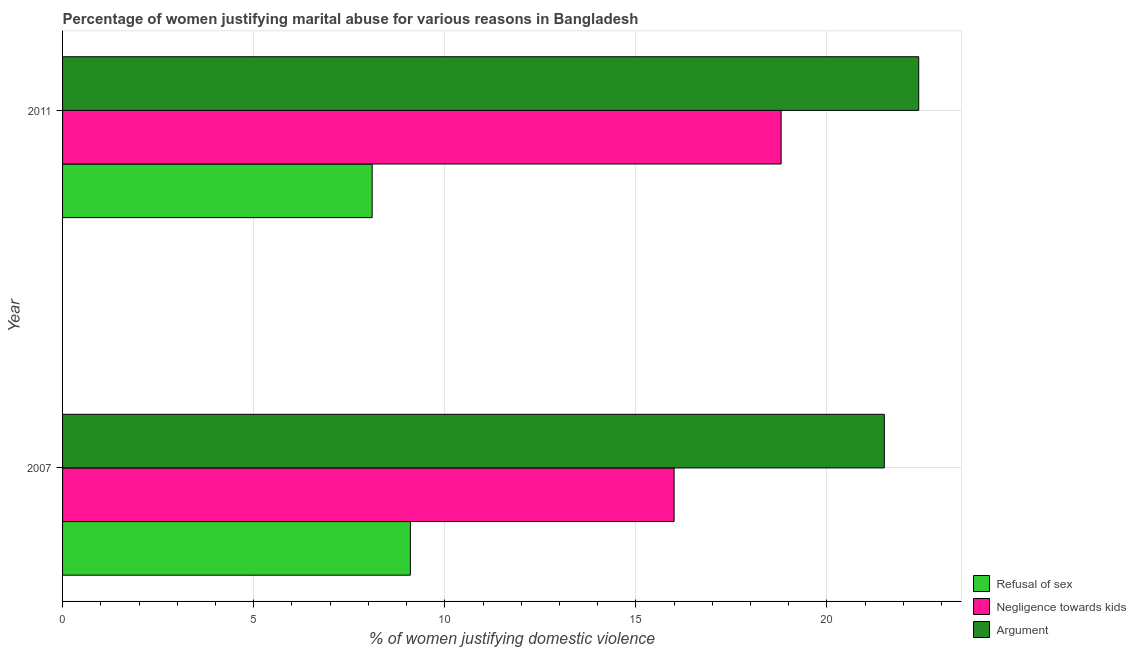How many different coloured bars are there?
Your response must be concise. 3. How many groups of bars are there?
Your answer should be compact. 2. Are the number of bars per tick equal to the number of legend labels?
Keep it short and to the point. Yes. How many bars are there on the 1st tick from the top?
Ensure brevity in your answer.  3. What is the label of the 2nd group of bars from the top?
Your response must be concise. 2007. In how many cases, is the number of bars for a given year not equal to the number of legend labels?
Provide a succinct answer. 0. Across all years, what is the maximum percentage of women justifying domestic violence due to negligence towards kids?
Offer a terse response. 18.8. Across all years, what is the minimum percentage of women justifying domestic violence due to negligence towards kids?
Provide a succinct answer. 16. In which year was the percentage of women justifying domestic violence due to arguments maximum?
Your response must be concise. 2011. What is the total percentage of women justifying domestic violence due to arguments in the graph?
Your response must be concise. 43.9. What is the difference between the percentage of women justifying domestic violence due to arguments in 2007 and that in 2011?
Give a very brief answer. -0.9. What is the difference between the percentage of women justifying domestic violence due to refusal of sex in 2007 and the percentage of women justifying domestic violence due to negligence towards kids in 2011?
Give a very brief answer. -9.7. What is the average percentage of women justifying domestic violence due to arguments per year?
Your answer should be very brief. 21.95. What is the ratio of the percentage of women justifying domestic violence due to refusal of sex in 2007 to that in 2011?
Provide a short and direct response. 1.12. Is the percentage of women justifying domestic violence due to arguments in 2007 less than that in 2011?
Provide a succinct answer. Yes. What does the 2nd bar from the top in 2007 represents?
Make the answer very short. Negligence towards kids. What does the 2nd bar from the bottom in 2011 represents?
Keep it short and to the point. Negligence towards kids. Is it the case that in every year, the sum of the percentage of women justifying domestic violence due to refusal of sex and percentage of women justifying domestic violence due to negligence towards kids is greater than the percentage of women justifying domestic violence due to arguments?
Ensure brevity in your answer.  Yes. Are the values on the major ticks of X-axis written in scientific E-notation?
Give a very brief answer. No. How many legend labels are there?
Your response must be concise. 3. What is the title of the graph?
Keep it short and to the point. Percentage of women justifying marital abuse for various reasons in Bangladesh. What is the label or title of the X-axis?
Your answer should be very brief. % of women justifying domestic violence. What is the label or title of the Y-axis?
Offer a very short reply. Year. What is the % of women justifying domestic violence in Refusal of sex in 2007?
Make the answer very short. 9.1. What is the % of women justifying domestic violence of Negligence towards kids in 2007?
Offer a terse response. 16. What is the % of women justifying domestic violence in Argument in 2007?
Give a very brief answer. 21.5. What is the % of women justifying domestic violence of Negligence towards kids in 2011?
Make the answer very short. 18.8. What is the % of women justifying domestic violence of Argument in 2011?
Ensure brevity in your answer.  22.4. Across all years, what is the maximum % of women justifying domestic violence in Argument?
Your answer should be compact. 22.4. Across all years, what is the minimum % of women justifying domestic violence of Negligence towards kids?
Give a very brief answer. 16. Across all years, what is the minimum % of women justifying domestic violence of Argument?
Give a very brief answer. 21.5. What is the total % of women justifying domestic violence in Refusal of sex in the graph?
Offer a very short reply. 17.2. What is the total % of women justifying domestic violence of Negligence towards kids in the graph?
Offer a terse response. 34.8. What is the total % of women justifying domestic violence of Argument in the graph?
Keep it short and to the point. 43.9. What is the difference between the % of women justifying domestic violence of Argument in 2007 and that in 2011?
Your answer should be compact. -0.9. What is the average % of women justifying domestic violence in Negligence towards kids per year?
Provide a succinct answer. 17.4. What is the average % of women justifying domestic violence of Argument per year?
Your response must be concise. 21.95. In the year 2007, what is the difference between the % of women justifying domestic violence of Refusal of sex and % of women justifying domestic violence of Argument?
Offer a very short reply. -12.4. In the year 2011, what is the difference between the % of women justifying domestic violence of Refusal of sex and % of women justifying domestic violence of Negligence towards kids?
Provide a short and direct response. -10.7. In the year 2011, what is the difference between the % of women justifying domestic violence in Refusal of sex and % of women justifying domestic violence in Argument?
Keep it short and to the point. -14.3. What is the ratio of the % of women justifying domestic violence of Refusal of sex in 2007 to that in 2011?
Provide a short and direct response. 1.12. What is the ratio of the % of women justifying domestic violence in Negligence towards kids in 2007 to that in 2011?
Your response must be concise. 0.85. What is the ratio of the % of women justifying domestic violence in Argument in 2007 to that in 2011?
Your answer should be very brief. 0.96. What is the difference between the highest and the second highest % of women justifying domestic violence in Negligence towards kids?
Make the answer very short. 2.8. What is the difference between the highest and the lowest % of women justifying domestic violence of Negligence towards kids?
Keep it short and to the point. 2.8. 